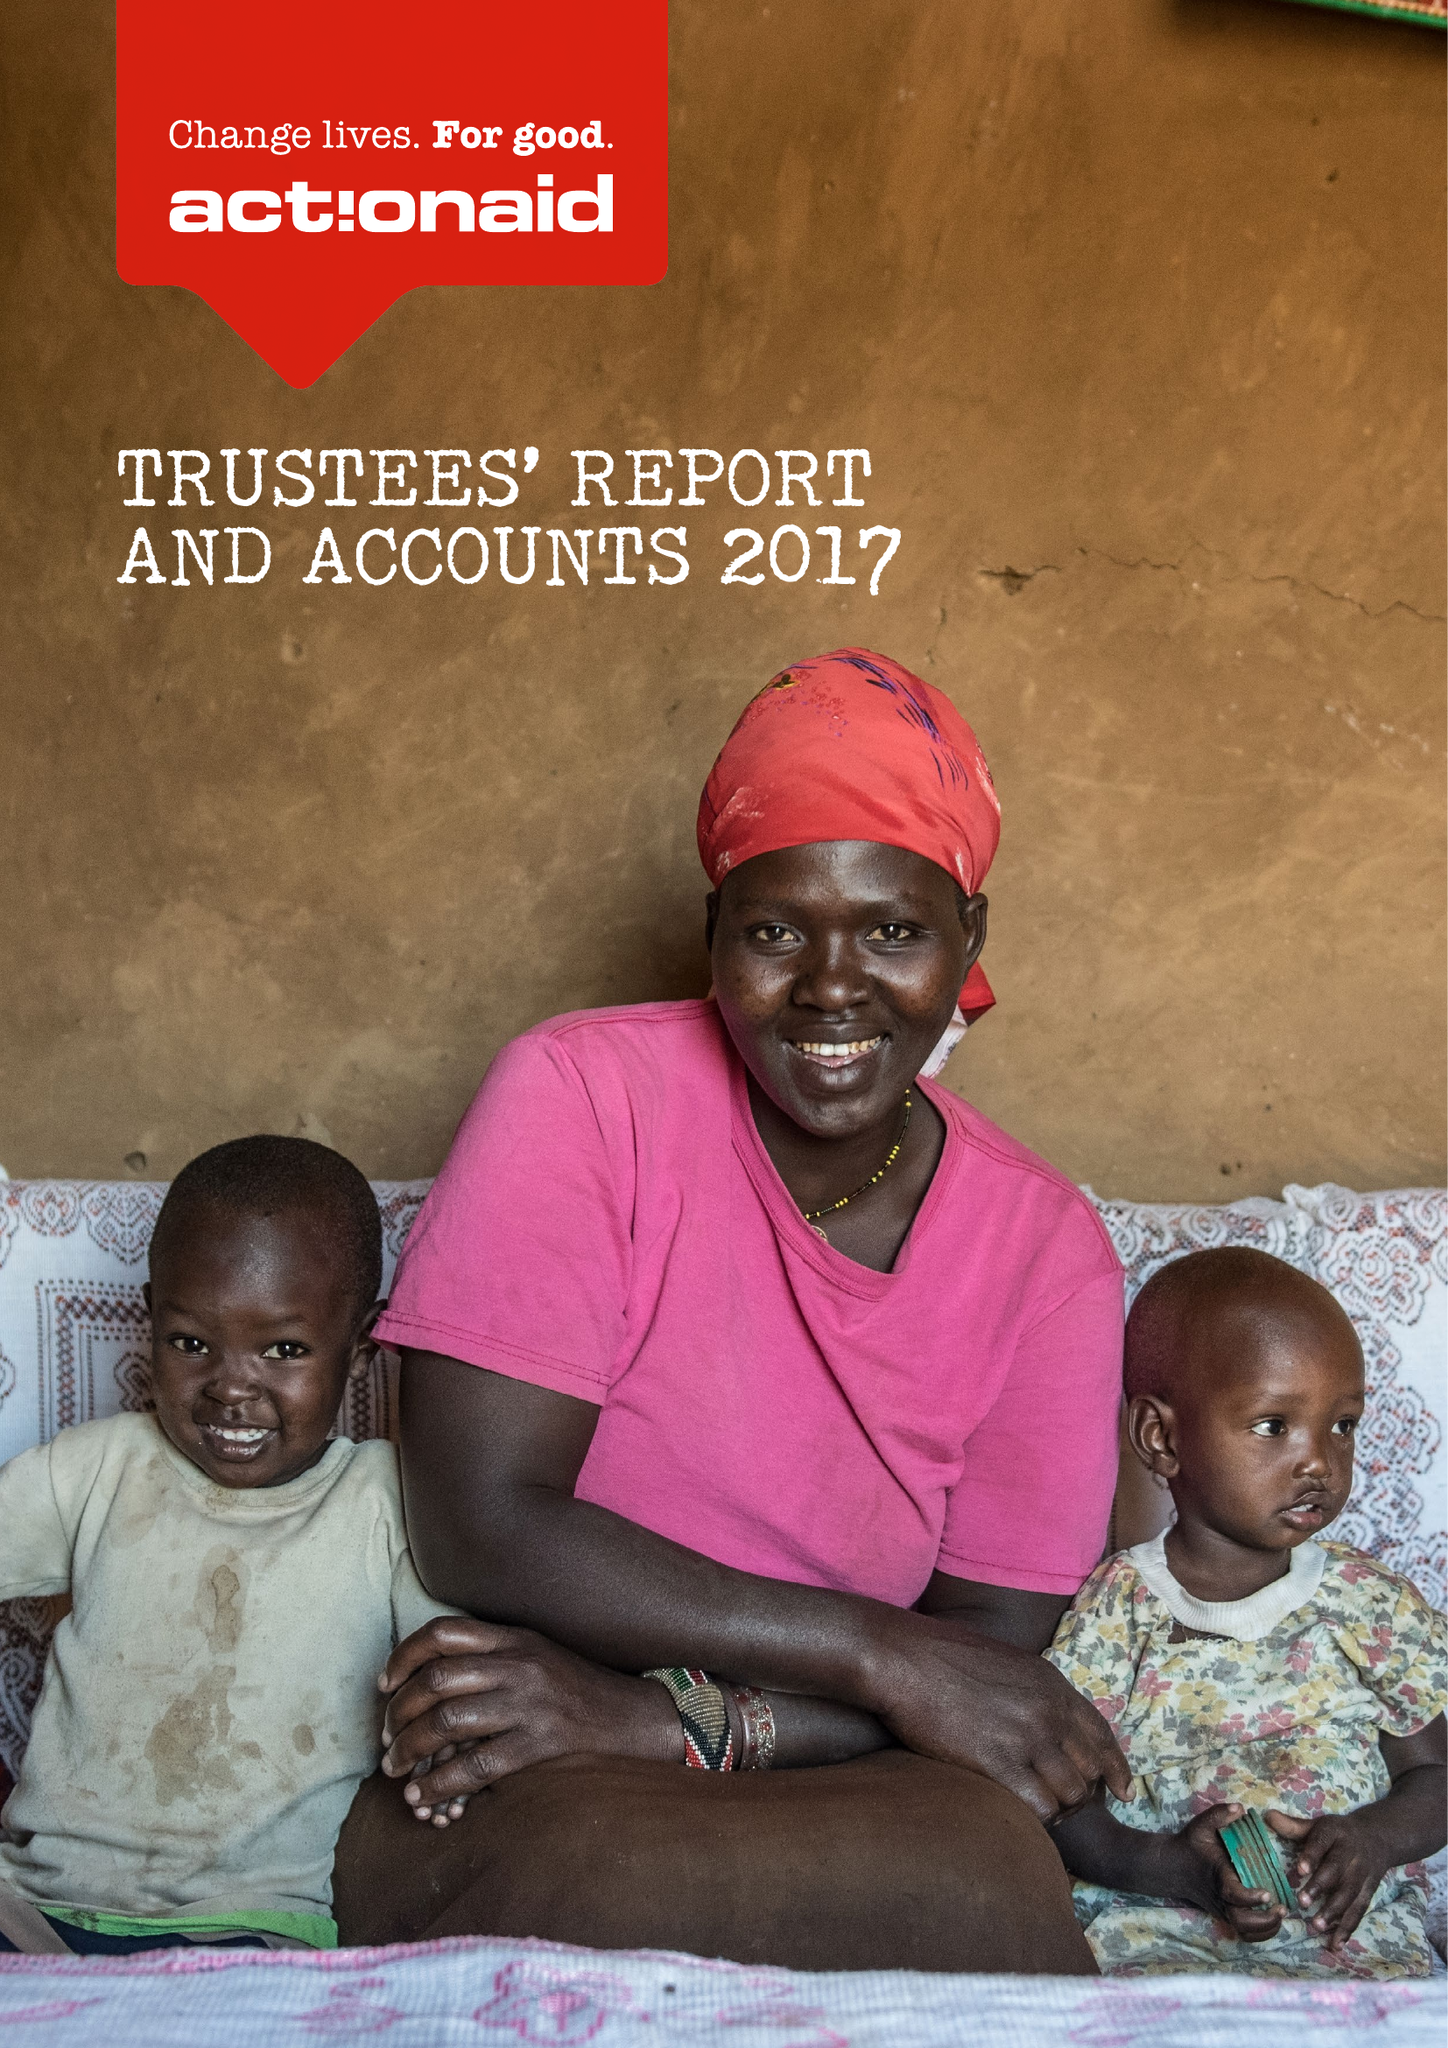What is the value for the charity_number?
Answer the question using a single word or phrase. 274467 